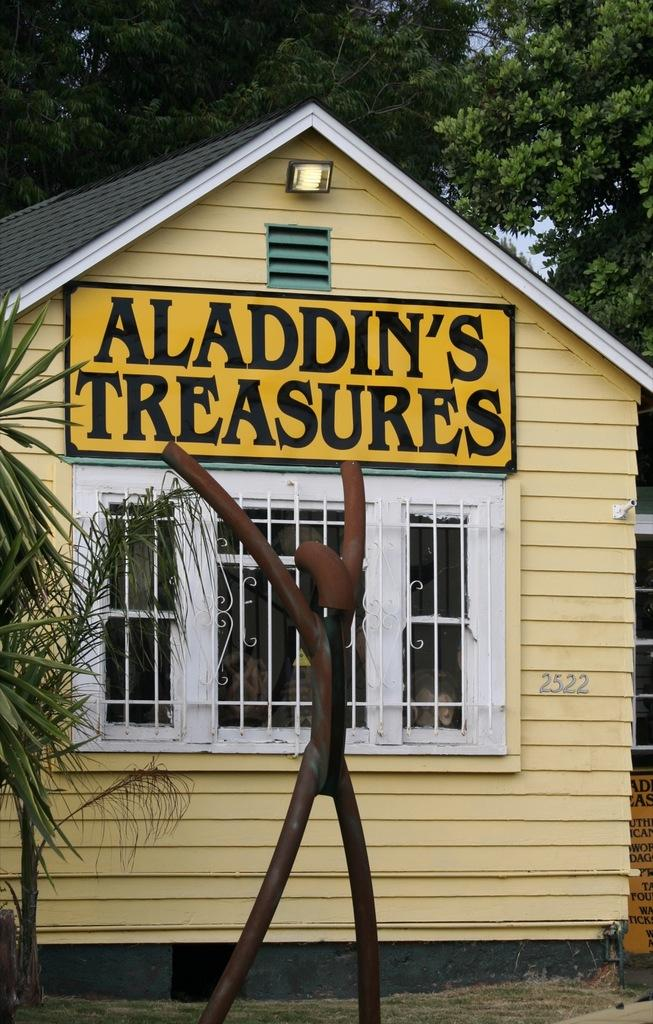What type of structure is visible in the image? There is a house in the image. What else can be seen in the image besides the house? There are boards, trees, and plants visible in the image. What is written on the boards? There is text on the boards. How many apples are hanging from the trees in the image? There are no apples visible in the image; only trees and plants are present. What type of insurance is being advertised on the street in the image? There is no street or insurance advertisement present in the image. 